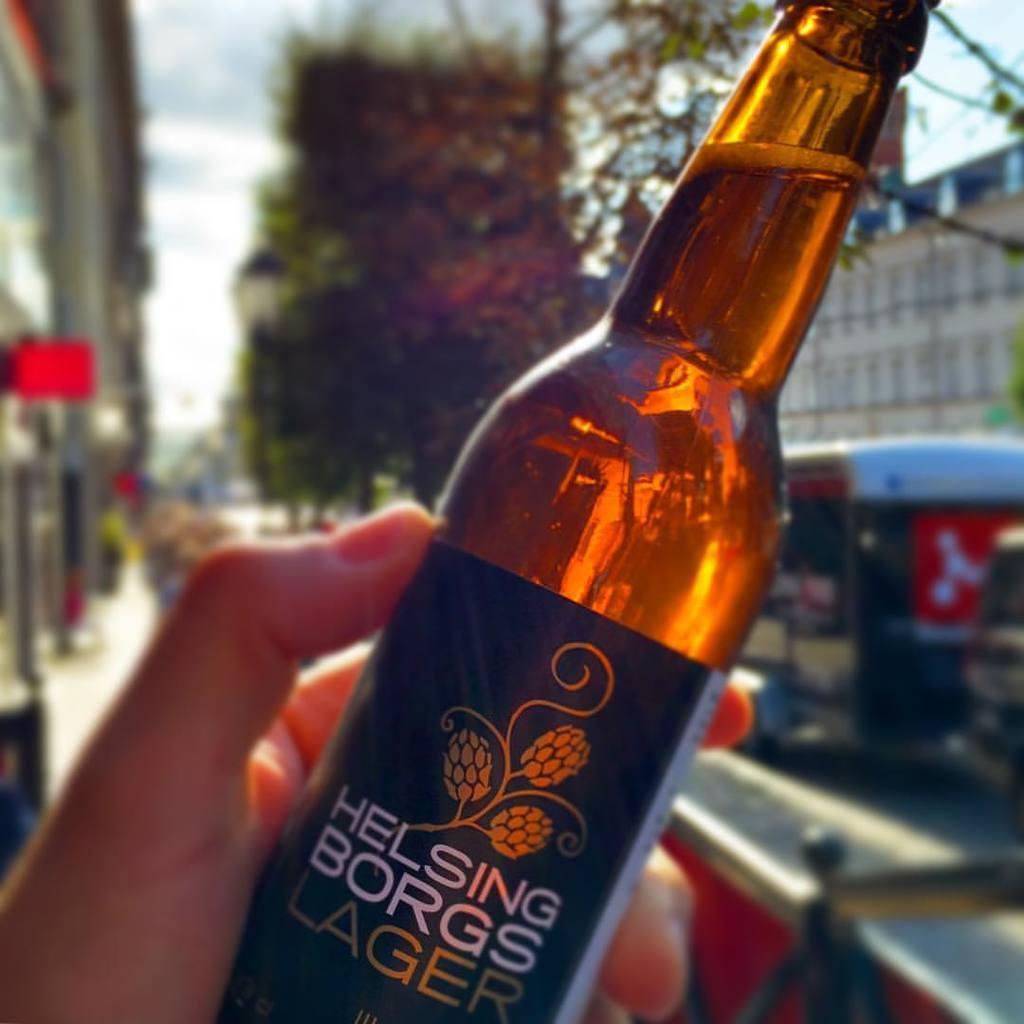In one or two sentences, can you explain what this image depicts? In this image I can see a hand of a person is holding a bottle. In the background I can see few trees and few buildings. 